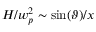<formula> <loc_0><loc_0><loc_500><loc_500>H / w _ { p } ^ { 2 } \sim \sin ( \vartheta ) / x</formula> 